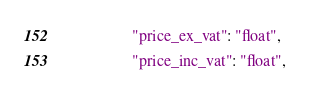<code> <loc_0><loc_0><loc_500><loc_500><_JavaScript_>				"price_ex_vat": "float",
				"price_inc_vat": "float",</code> 